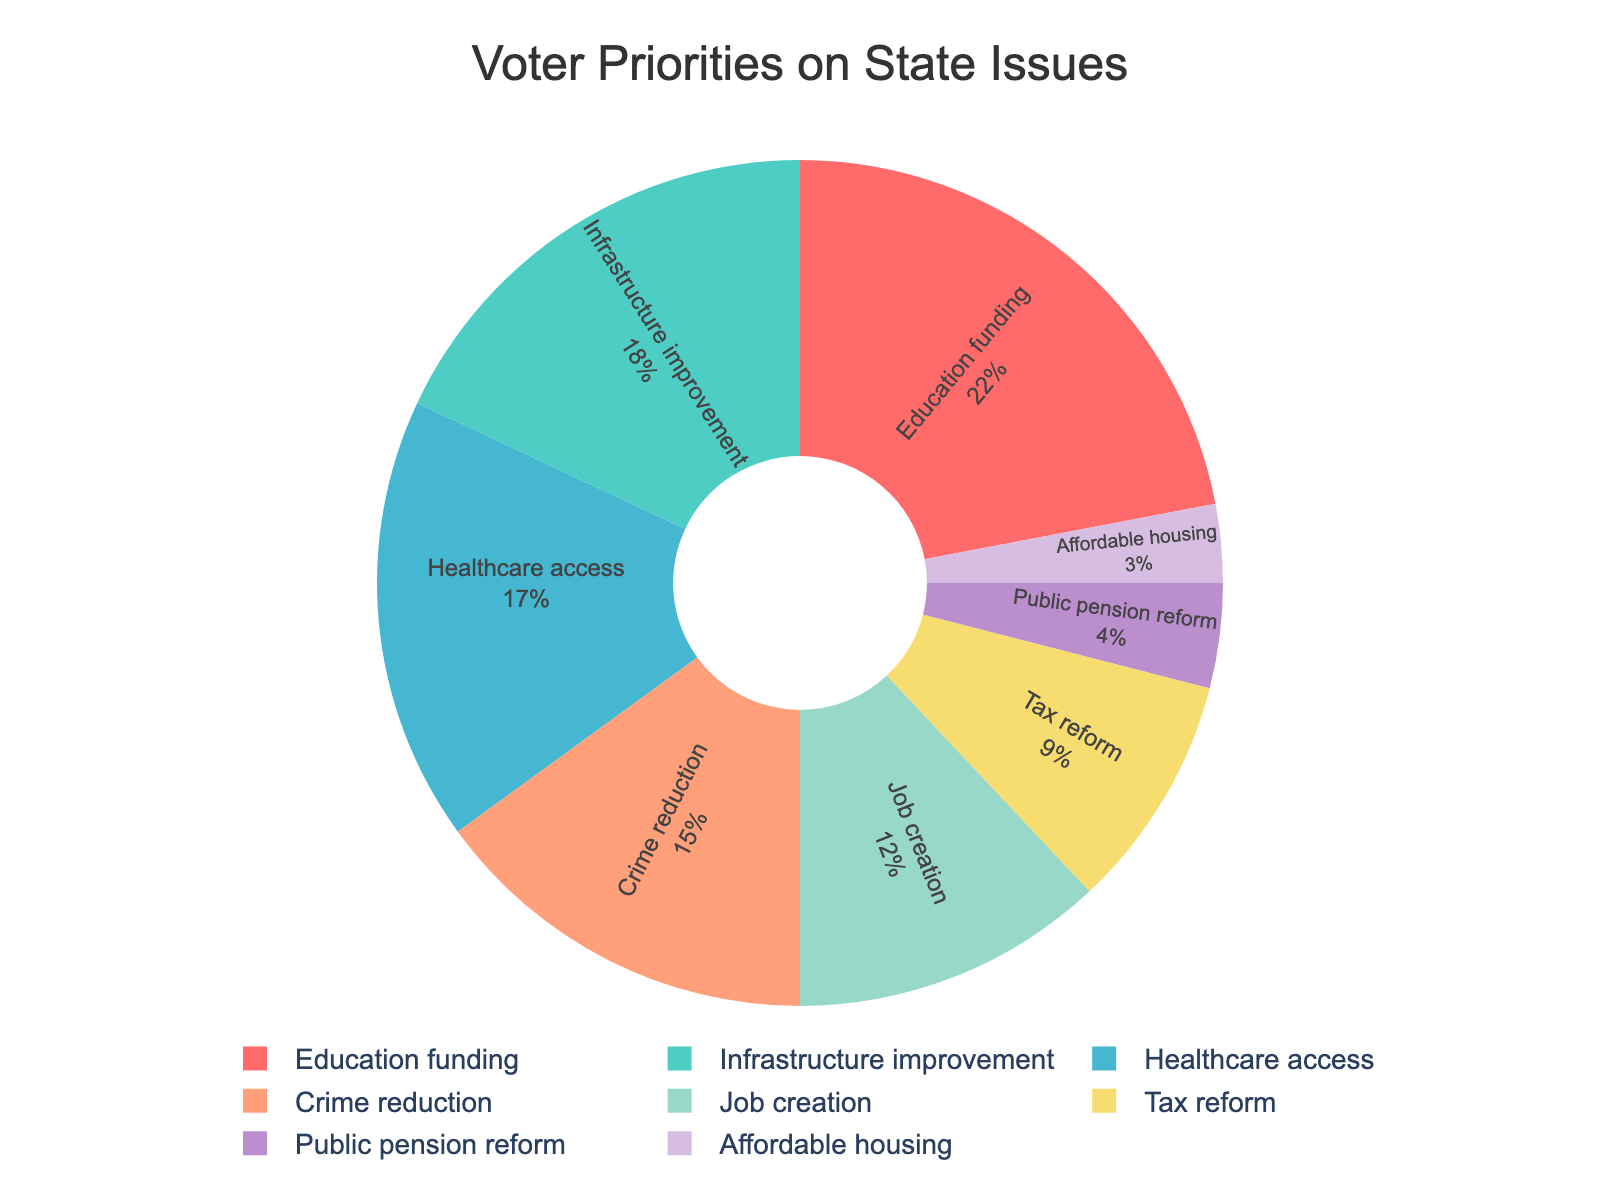What percentage of voters prioritize Education funding and Healthcare access combined? Add the percentages for Education funding and Healthcare access from the pie chart: 22% + 17% = 39%.
Answer: 39% How does the voter priority for Infrastructure improvement compare to Crime reduction? Compare the percentages for Infrastructure improvement (18%) and Crime reduction (15%) from the pie chart. Infrastructure improvement has a higher percentage.
Answer: Infrastructure improvement is greater Which issue has the smallest voter priority, and what is its percentage? Identify the smallest percentage in the pie chart, which corresponds to Affordable housing (3%).
Answer: Affordable housing, 3% What is the total percentage of voter priorities for Healthcare access, Job creation, and Crime reduction? Sum the percentages for Healthcare access (17%), Job creation (12%), and Crime reduction (15%): 17% + 12% + 15% = 44%.
Answer: 44% Out of the issues listed, which one has the second-highest voter priority? Review the pie chart and identify the highest and second-highest percentages. Education funding is the highest at 22%, and Infrastructure improvement is the second highest at 18%.
Answer: Infrastructure improvement If you combine the voter priorities for Public pension reform and Affordable housing, does it surpass the priority for Tax reform? Add the percentages for Public pension reform (4%) and Affordable housing (3%): 4% + 3% = 7%. Compare this to Tax reform (9%). Since 7% is less than 9%, it does not surpass.
Answer: No What is the difference between the voter priorities for Education funding and Job creation? Subtract the percentage for Job creation (12%) from the percentage for Education funding (22%): 22% - 12% = 10%.
Answer: 10% What is the combined percentage of voter priorities for issues receiving less than 10% each? Sum the percentages for Tax reform (9%), Public pension reform (4%), and Affordable housing (3%): 9% + 4% + 3% = 16%.
Answer: 16% Which issue has a greater voter priority: Tax reform or Public pension reform? Compare the percentages for Tax reform (9%) and Public pension reform (4%) from the pie chart. Tax reform has a higher percentage.
Answer: Tax reform What is the average percentage of voter priorities for all issues excluding the top three priorities? Exclude the top three priorities (Education funding, Infrastructure improvement, Healthcare access). Calculate the average of the remaining issues: (Crime reduction 15% + Job creation 12% + Tax reform 9% + Public pension reform 4% + Affordable housing 3%) / 5 = 43% / 5 = 8.6%.
Answer: 8.6% 